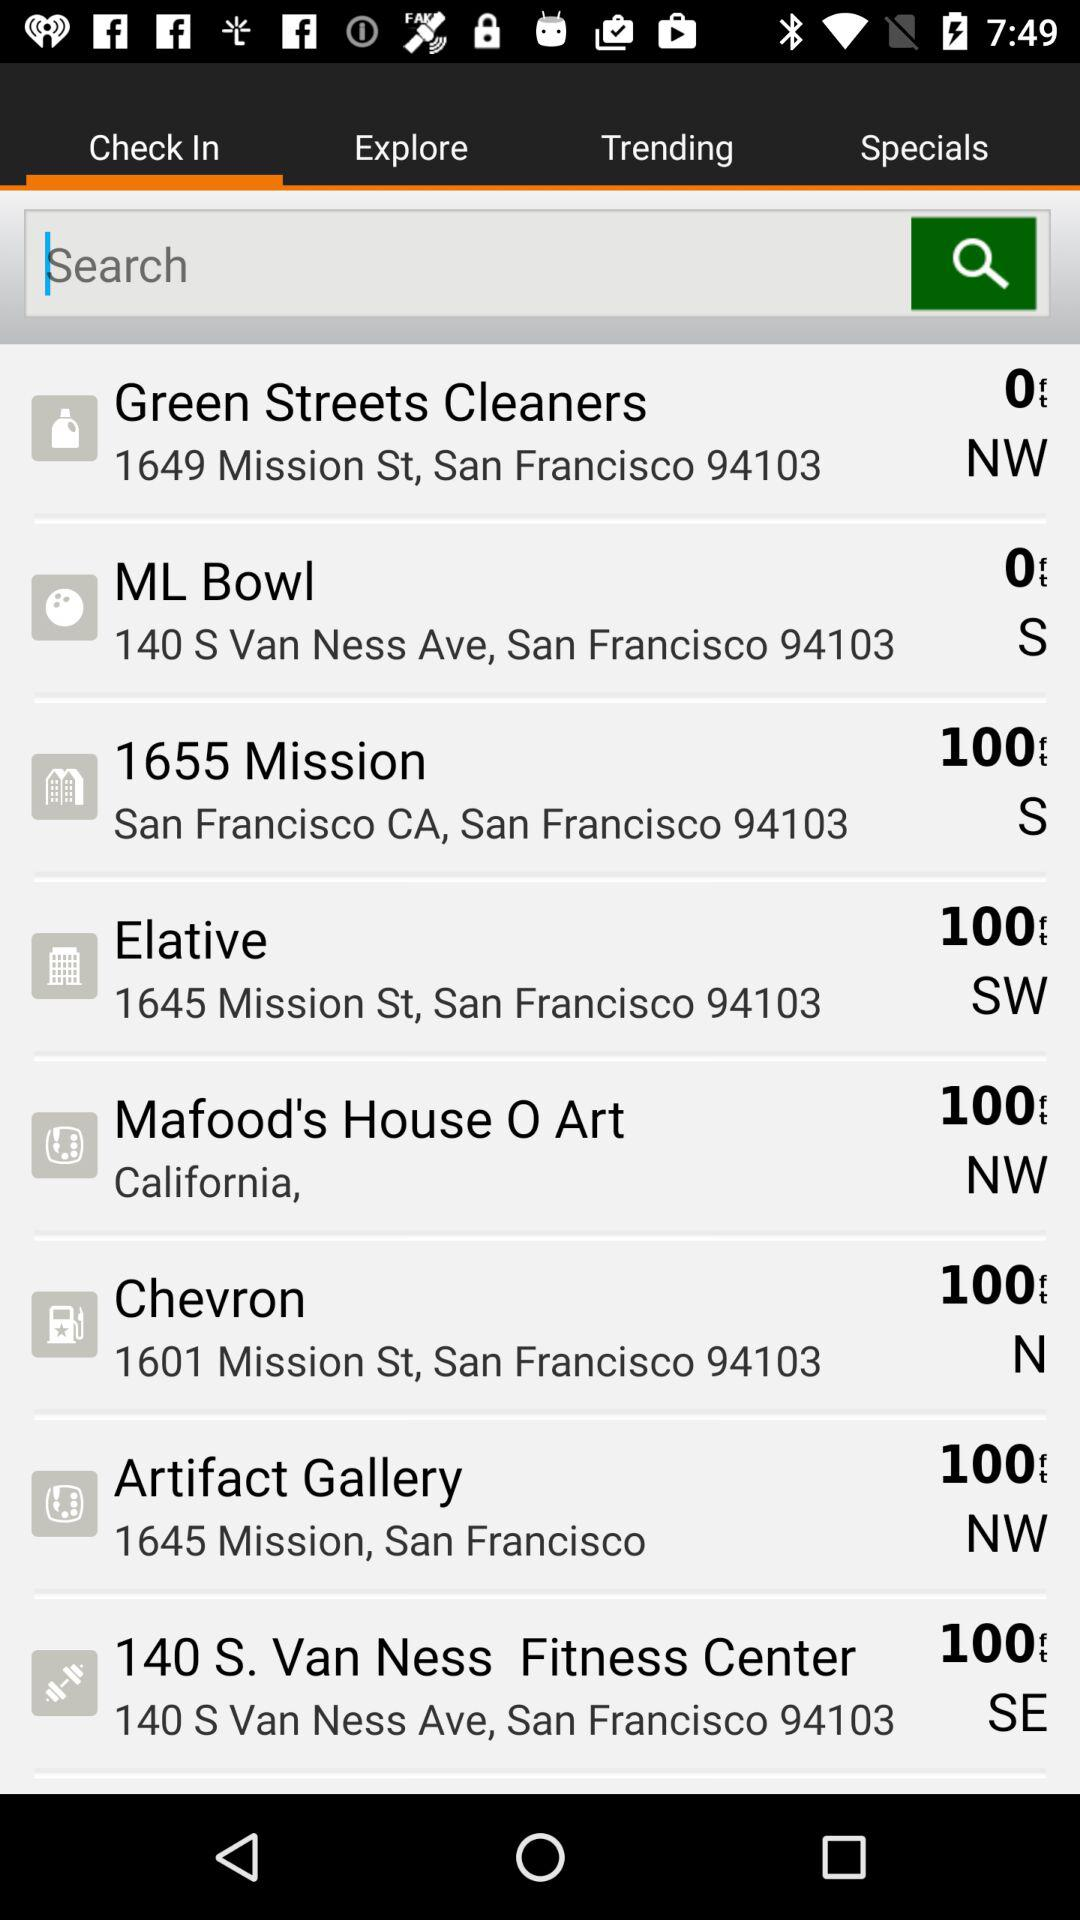Where is Chevron? Chevron is at 1601 Mission St., San Francisco, 94103. 